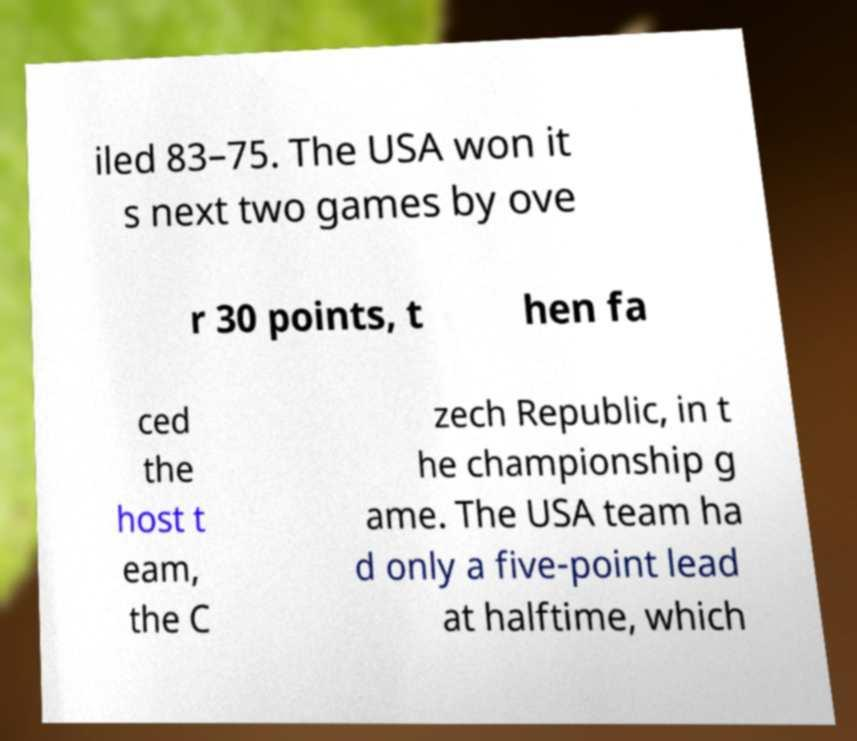Could you assist in decoding the text presented in this image and type it out clearly? iled 83–75. The USA won it s next two games by ove r 30 points, t hen fa ced the host t eam, the C zech Republic, in t he championship g ame. The USA team ha d only a five-point lead at halftime, which 